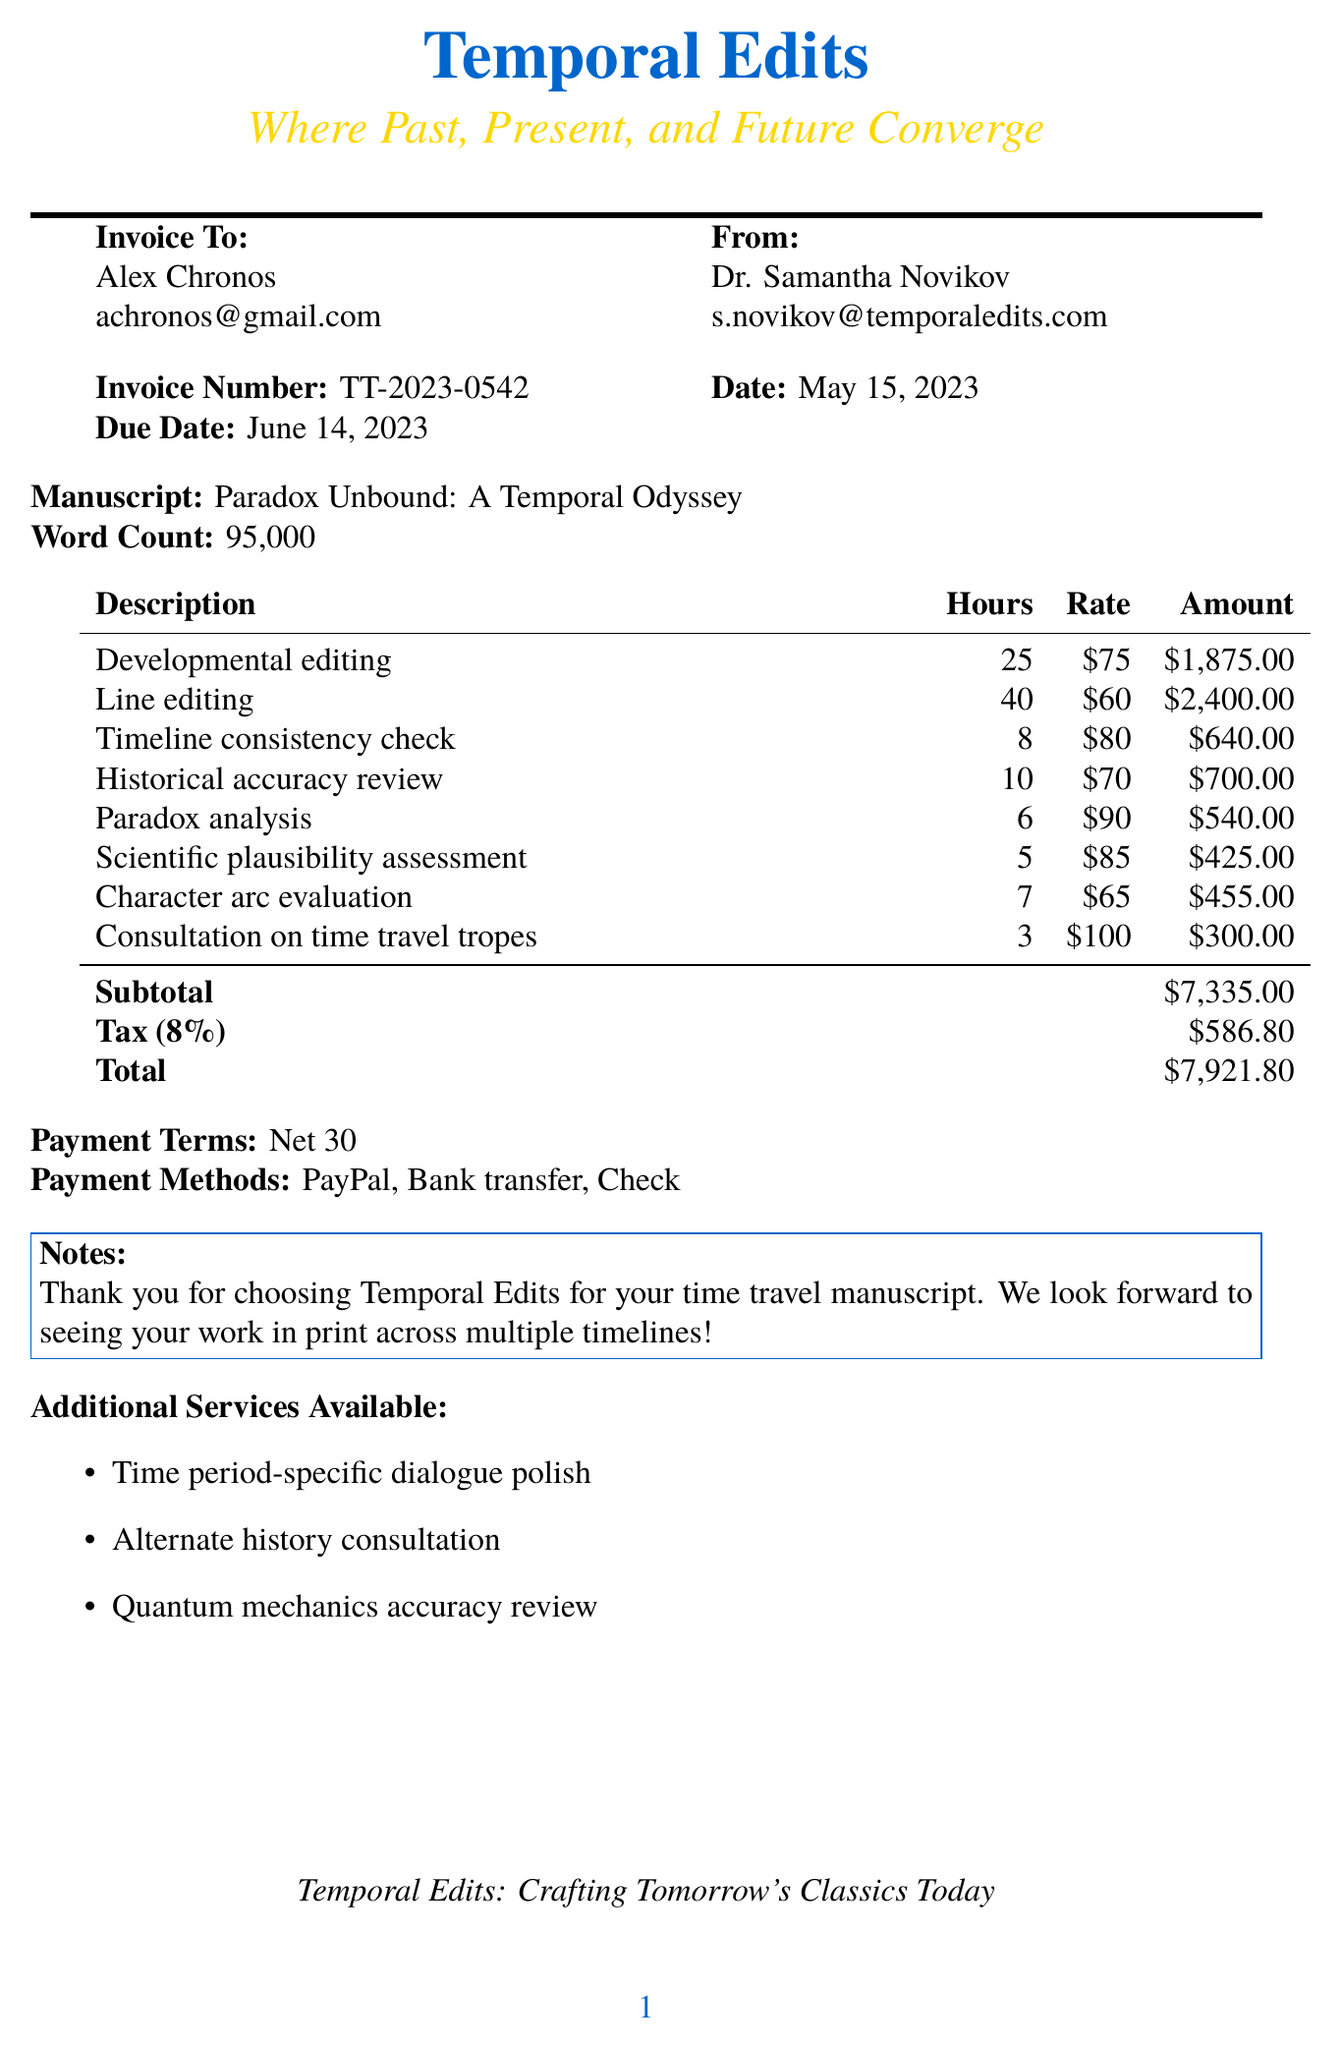What is the invoice number? The invoice number is a unique identifier assigned to the invoice, found in the header section.
Answer: TT-2023-0542 Who is the editor? The editor's name is provided in the contact information, representing the service provider.
Answer: Dr. Samantha Novikov What is the total amount due? The total amount due is listed at the bottom of the invoice after tax calculations.
Answer: $7,921.80 How many hours were spent on line editing? The hours for line editing are noted in the line item breakdown, indicating the time spent on this specific service.
Answer: 40 What is the tax rate applied? The tax rate is specified in the invoice and impacts the total amount after subtotal calculations.
Answer: 8% What is the manuscript title? The manuscript title is the creative work for which the editing services are provided, listed clearly in the document.
Answer: Paradox Unbound: A Temporal Odyssey What payment terms are listed? The payment terms detail the timeline for payment expected from the client and are standard for invoices.
Answer: Net 30 Which service has the highest hourly rate? To find the service with the highest hourly rate, one would compare the rates in the line-item breakdown.
Answer: Consultation on time travel tropes What are the additional services available? The additional services are indicated towards the end of the document and offer more options beyond the initial scope.
Answer: Time period-specific dialogue polish, Alternate history consultation, Quantum mechanics accuracy review 